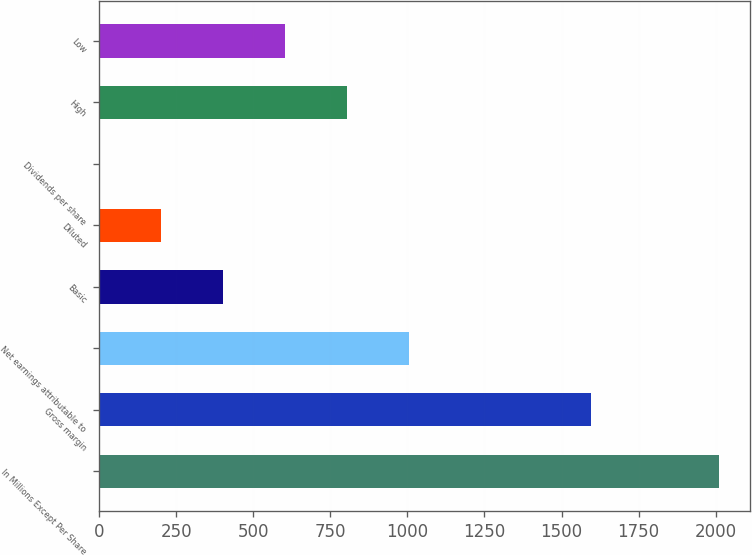Convert chart to OTSL. <chart><loc_0><loc_0><loc_500><loc_500><bar_chart><fcel>In Millions Except Per Share<fcel>Gross margin<fcel>Net earnings attributable to<fcel>Basic<fcel>Diluted<fcel>Dividends per share<fcel>High<fcel>Low<nl><fcel>2012<fcel>1594.7<fcel>1006.15<fcel>402.64<fcel>201.47<fcel>0.3<fcel>804.98<fcel>603.81<nl></chart> 